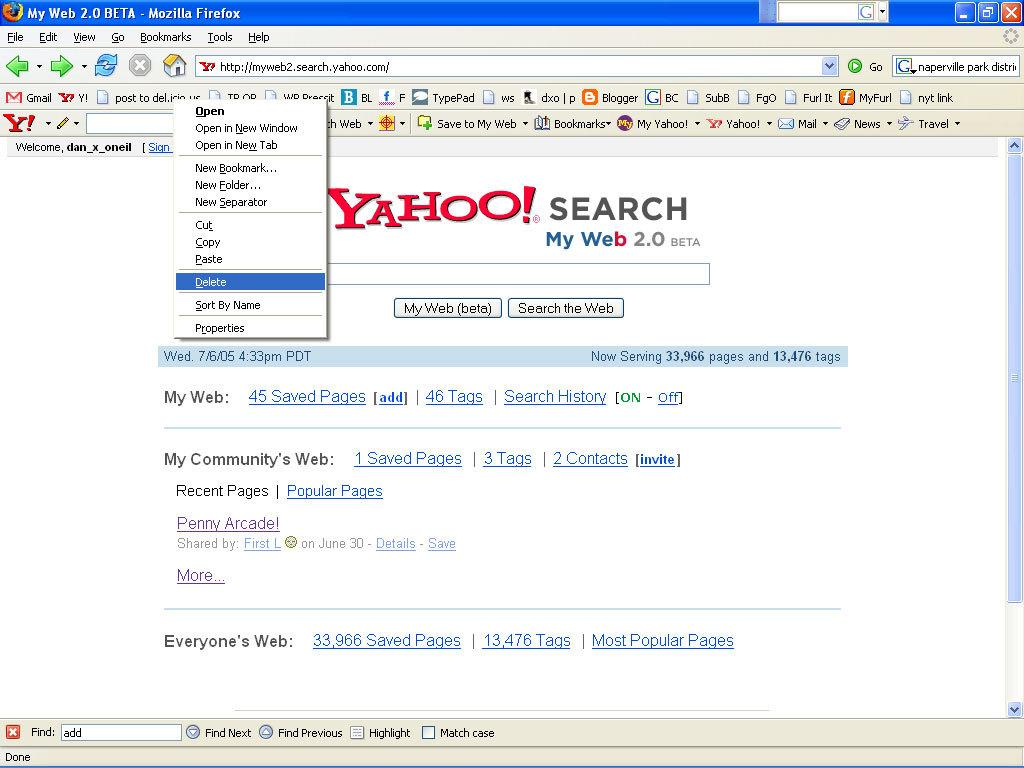<image>
Provide a brief description of the given image. A screenshot of a webpage with Yahoo Search on it 